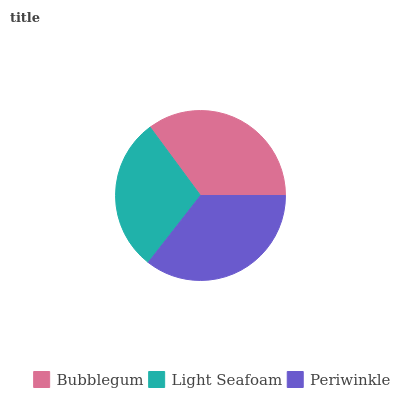Is Light Seafoam the minimum?
Answer yes or no. Yes. Is Periwinkle the maximum?
Answer yes or no. Yes. Is Periwinkle the minimum?
Answer yes or no. No. Is Light Seafoam the maximum?
Answer yes or no. No. Is Periwinkle greater than Light Seafoam?
Answer yes or no. Yes. Is Light Seafoam less than Periwinkle?
Answer yes or no. Yes. Is Light Seafoam greater than Periwinkle?
Answer yes or no. No. Is Periwinkle less than Light Seafoam?
Answer yes or no. No. Is Bubblegum the high median?
Answer yes or no. Yes. Is Bubblegum the low median?
Answer yes or no. Yes. Is Periwinkle the high median?
Answer yes or no. No. Is Periwinkle the low median?
Answer yes or no. No. 